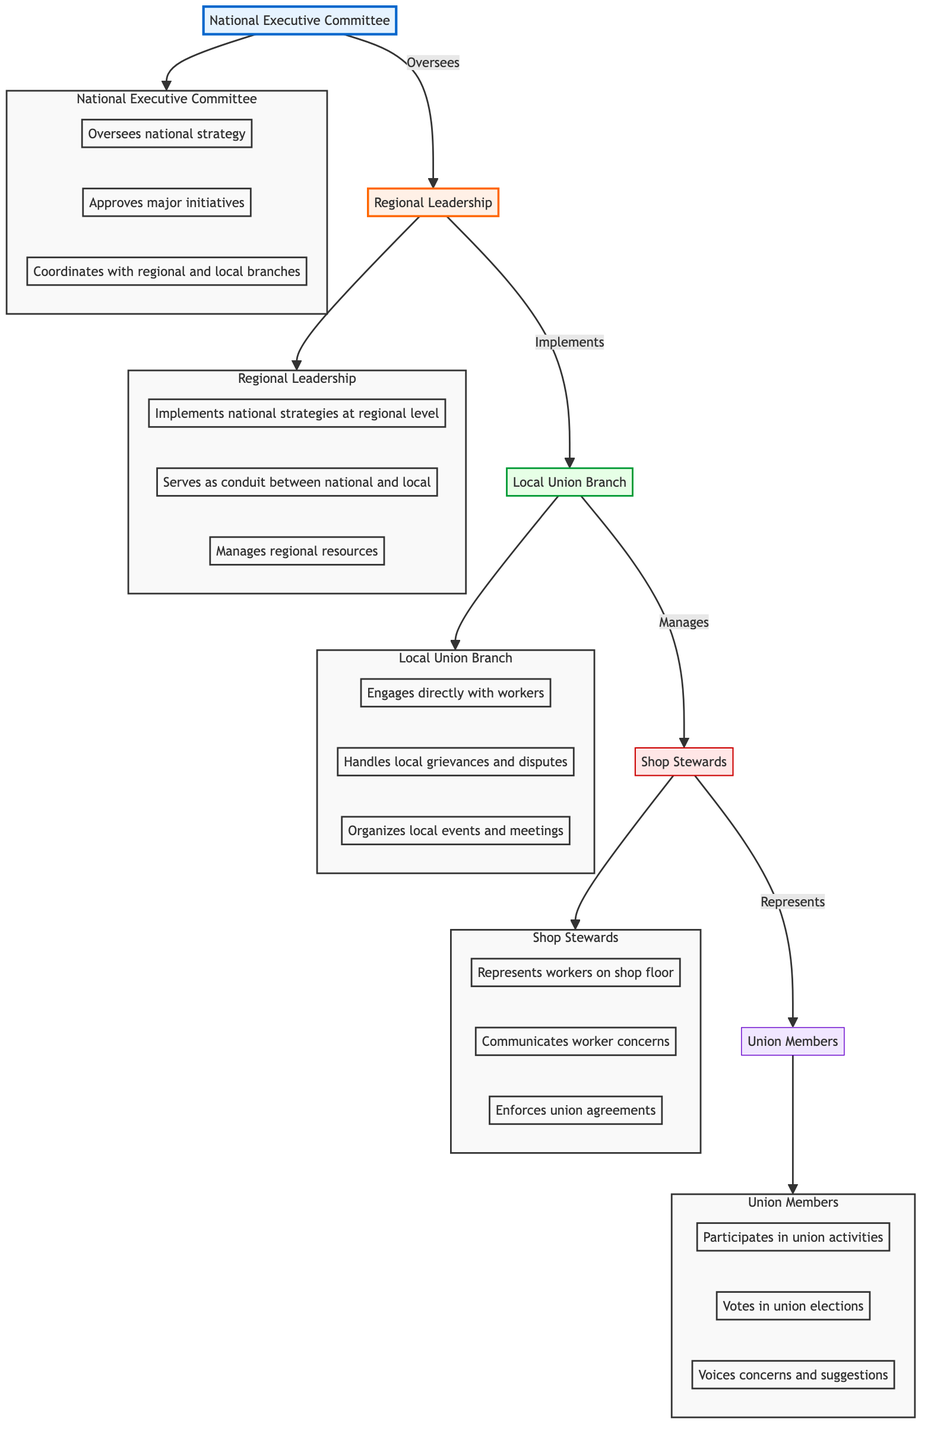What is the highest level in the hierarchical structure? The highest level in the hierarchical structure is represented by the National Executive Committee, which is the top node in the diagram.
Answer: National Executive Committee How many roles are listed under the Local Union Branch? The Local Union Branch has three roles listed in the diagram: engaging with workers, handling grievances, and organizing events. Therefore, the count is three, which comes from directly observing the listed responsibilities under this node.
Answer: 3 Who represents workers on the shop floor? The Shop Stewards are specifically mentioned as representing workers on the shop floor within the diagram. They are connected to the Union Members node indicating their role.
Answer: Shop Stewards What responsibility does the Regional Leadership have in relation to national strategies? The Regional Leadership is responsible for implementing national strategies at the regional level, and this is indicated directly in the diagram as a connection between Regional Leadership and the National Executive Committee.
Answer: Implements national strategies at regional level What is the primary function of Local Union Branches? The primary function of Local Union Branches is to engage directly with workers, as indicated by the first responsibility listed under this node in the diagram, which highlights their direct interaction with members.
Answer: Engages directly with workers How many total elements are in the hierarchical structure? There are five elements in total within the hierarchical structure of labor unions, as listed directly in the diagram. These elements include the National Executive Committee, Regional Leadership, Local Union Branch, Shop Stewards, and Union Members.
Answer: 5 What type of feedback do Union Members provide? Union Members provide feedback by voicing concerns and suggestions, which is explicitly mentioned as one of their responsibilities in the diagram. This is crucial for their participation in the union.
Answer: Voices concerns and suggestions Which level communicates worker concerns to local branches? Shop Stewards are responsible for communicating worker concerns to local branches, as highlighted under their roles in the diagram, which connects them to both workers and the Local Union Branch.
Answer: Communicates worker concerns How does the National Executive Committee interact with Regional Leadership? The National Executive Committee oversees the Regional Leadership, which indicates a top-down approach in the hierarchical structure where decisions and strategies flow from the top to the regional level.
Answer: Oversees 